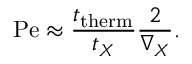<formula> <loc_0><loc_0><loc_500><loc_500>P e \approx { \frac { t _ { t h e r m } } { t _ { X } } } { \frac { 2 } { \nabla _ { X } } } .</formula> 